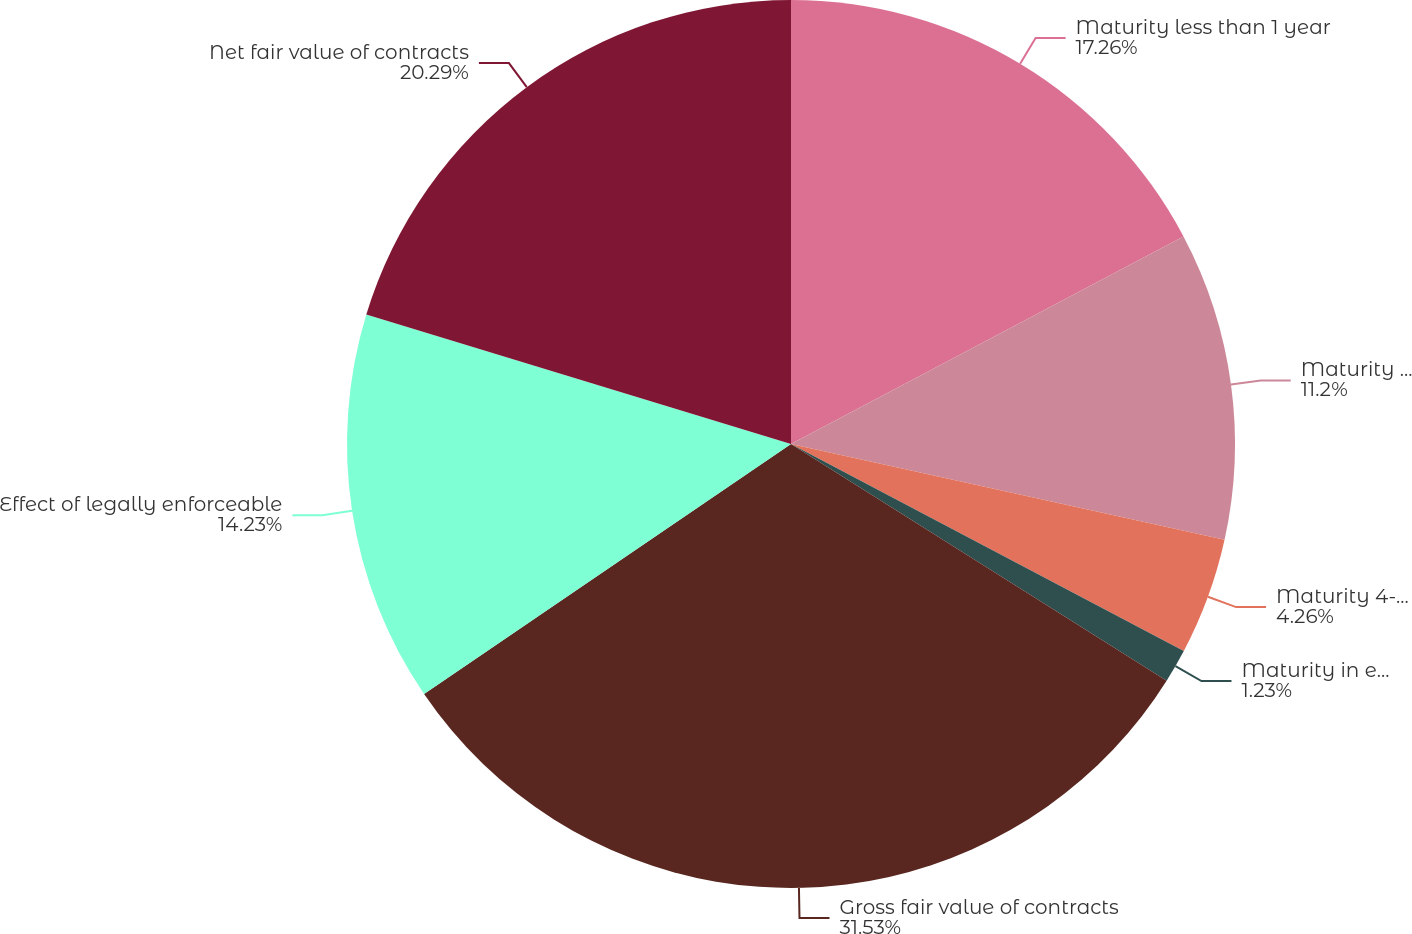Convert chart. <chart><loc_0><loc_0><loc_500><loc_500><pie_chart><fcel>Maturity less than 1 year<fcel>Maturity 1-3 years<fcel>Maturity 4-5 years<fcel>Maturity in excess of 5 years<fcel>Gross fair value of contracts<fcel>Effect of legally enforceable<fcel>Net fair value of contracts<nl><fcel>17.26%<fcel>11.2%<fcel>4.26%<fcel>1.23%<fcel>31.53%<fcel>14.23%<fcel>20.29%<nl></chart> 